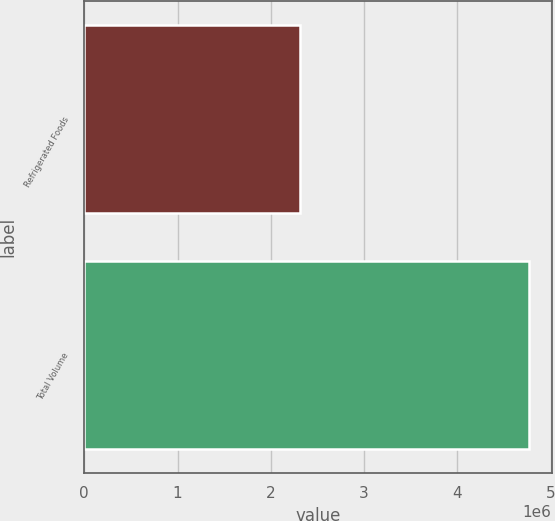Convert chart. <chart><loc_0><loc_0><loc_500><loc_500><bar_chart><fcel>Refrigerated Foods<fcel>Total Volume<nl><fcel>2.31525e+06<fcel>4.77048e+06<nl></chart> 